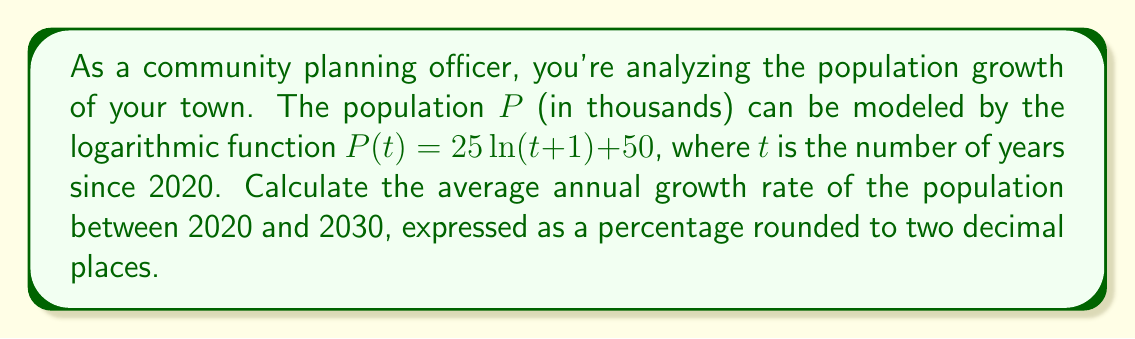Help me with this question. To solve this problem, we'll follow these steps:

1) First, let's calculate the population in 2020 (t = 0) and 2030 (t = 10):

   For 2020: $P(0) = 25 \ln(0+1) + 50 = 25 \ln(1) + 50 = 50$ thousand

   For 2030: $P(10) = 25 \ln(10+1) + 50 = 25 \ln(11) + 50 \approx 85.03$ thousand

2) Now we need to calculate the total growth rate over the 10-year period:

   Total growth rate = $\frac{P(10) - P(0)}{P(0)} = \frac{85.03 - 50}{50} \approx 0.7006$ or 70.06%

3) To find the average annual growth rate, we use the compound interest formula:

   $$(1 + r)^n = \frac{P(10)}{P(0)}$$

   Where $r$ is the annual growth rate and $n$ is the number of years (10 in this case).

4) Substituting our values:

   $$(1 + r)^{10} = \frac{85.03}{50} \approx 1.7006$$

5) Taking the 10th root of both sides:

   $$(1 + r) = (1.7006)^{\frac{1}{10}} \approx 1.0547$$

6) Subtract 1 and multiply by 100 to get the percentage:

   $r = (1.0547 - 1) * 100 \approx 5.47\%$
Answer: The average annual growth rate of the population between 2020 and 2030 is approximately 5.47%. 